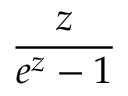<formula> <loc_0><loc_0><loc_500><loc_500>\frac { z } { e ^ { z } - 1 }</formula> 